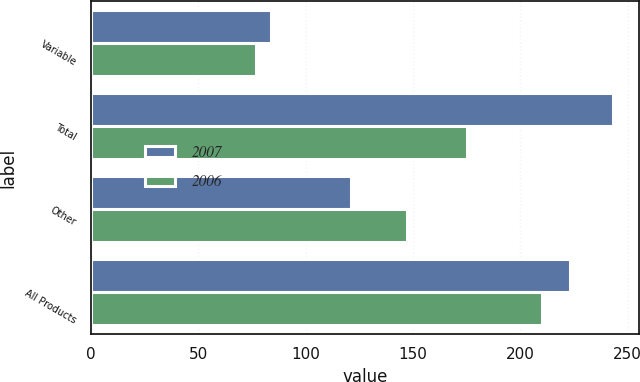Convert chart to OTSL. <chart><loc_0><loc_0><loc_500><loc_500><stacked_bar_chart><ecel><fcel>Variable<fcel>Total<fcel>Other<fcel>All Products<nl><fcel>2007<fcel>84<fcel>243<fcel>121<fcel>223<nl><fcel>2006<fcel>77<fcel>175<fcel>147<fcel>210<nl></chart> 